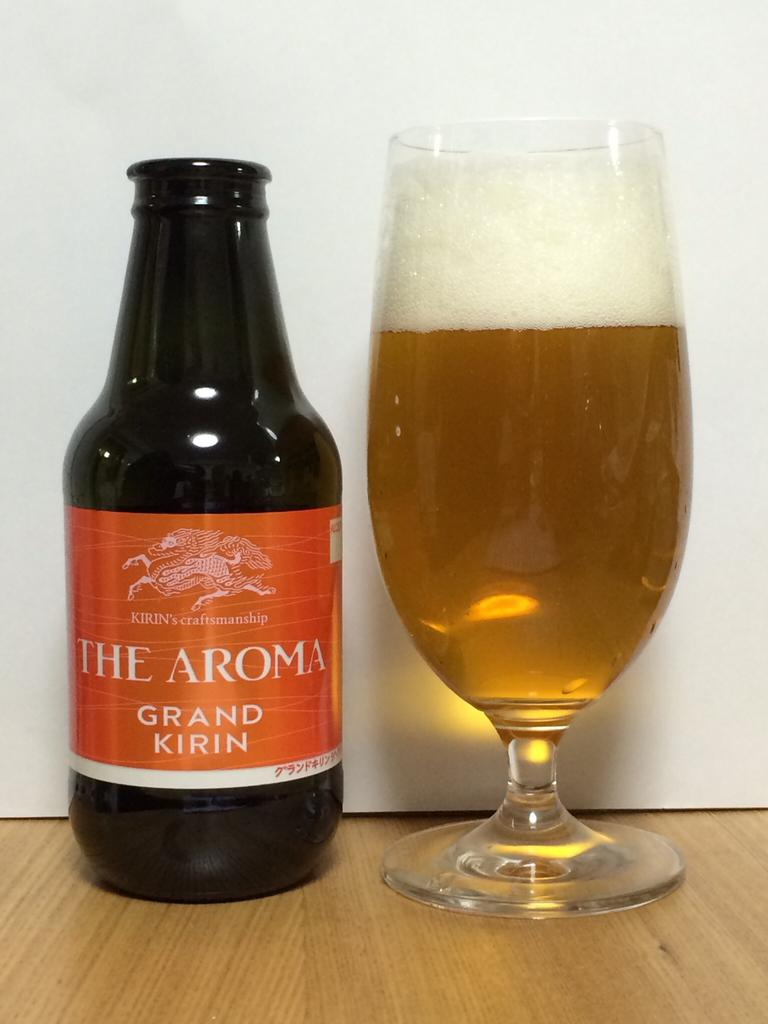Provide a one-sentence caption for the provided image. A glass almost full of beer next to a glass bottle of The Aroma Grand Kirin. 